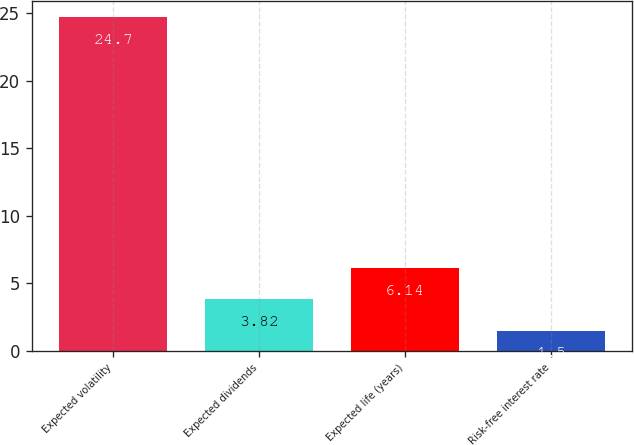Convert chart. <chart><loc_0><loc_0><loc_500><loc_500><bar_chart><fcel>Expected volatility<fcel>Expected dividends<fcel>Expected life (years)<fcel>Risk-free interest rate<nl><fcel>24.7<fcel>3.82<fcel>6.14<fcel>1.5<nl></chart> 